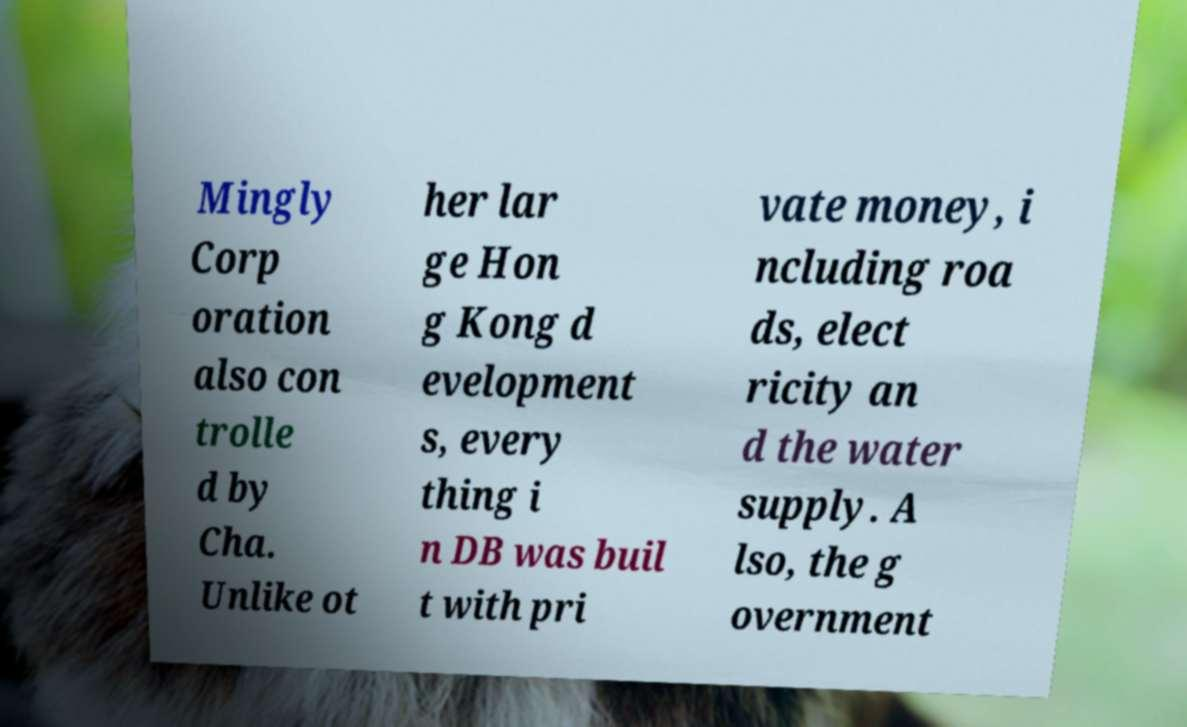I need the written content from this picture converted into text. Can you do that? Mingly Corp oration also con trolle d by Cha. Unlike ot her lar ge Hon g Kong d evelopment s, every thing i n DB was buil t with pri vate money, i ncluding roa ds, elect ricity an d the water supply. A lso, the g overnment 